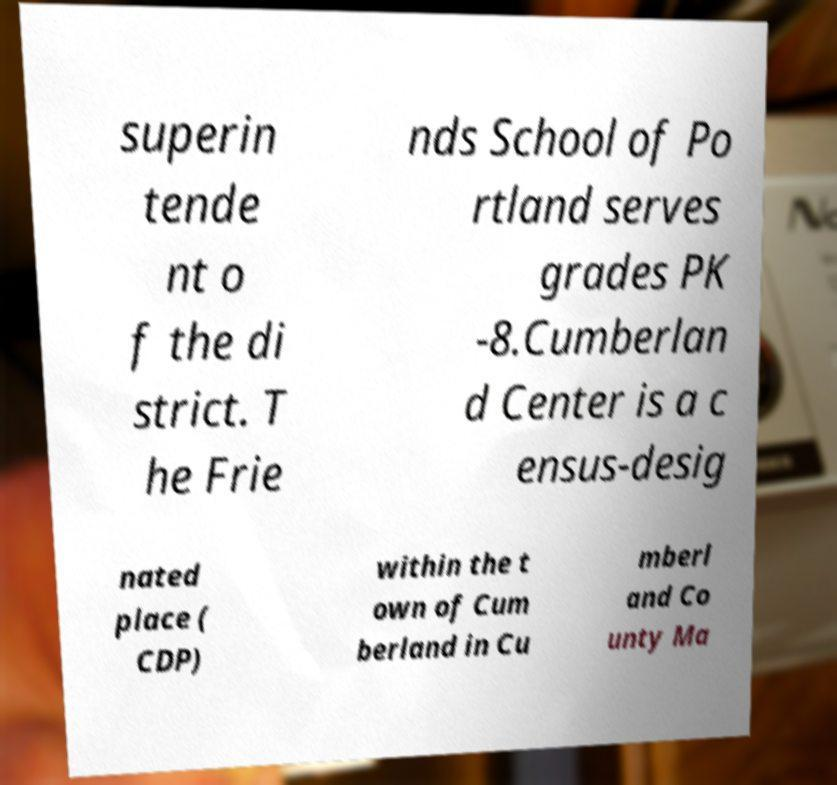Could you assist in decoding the text presented in this image and type it out clearly? superin tende nt o f the di strict. T he Frie nds School of Po rtland serves grades PK -8.Cumberlan d Center is a c ensus-desig nated place ( CDP) within the t own of Cum berland in Cu mberl and Co unty Ma 